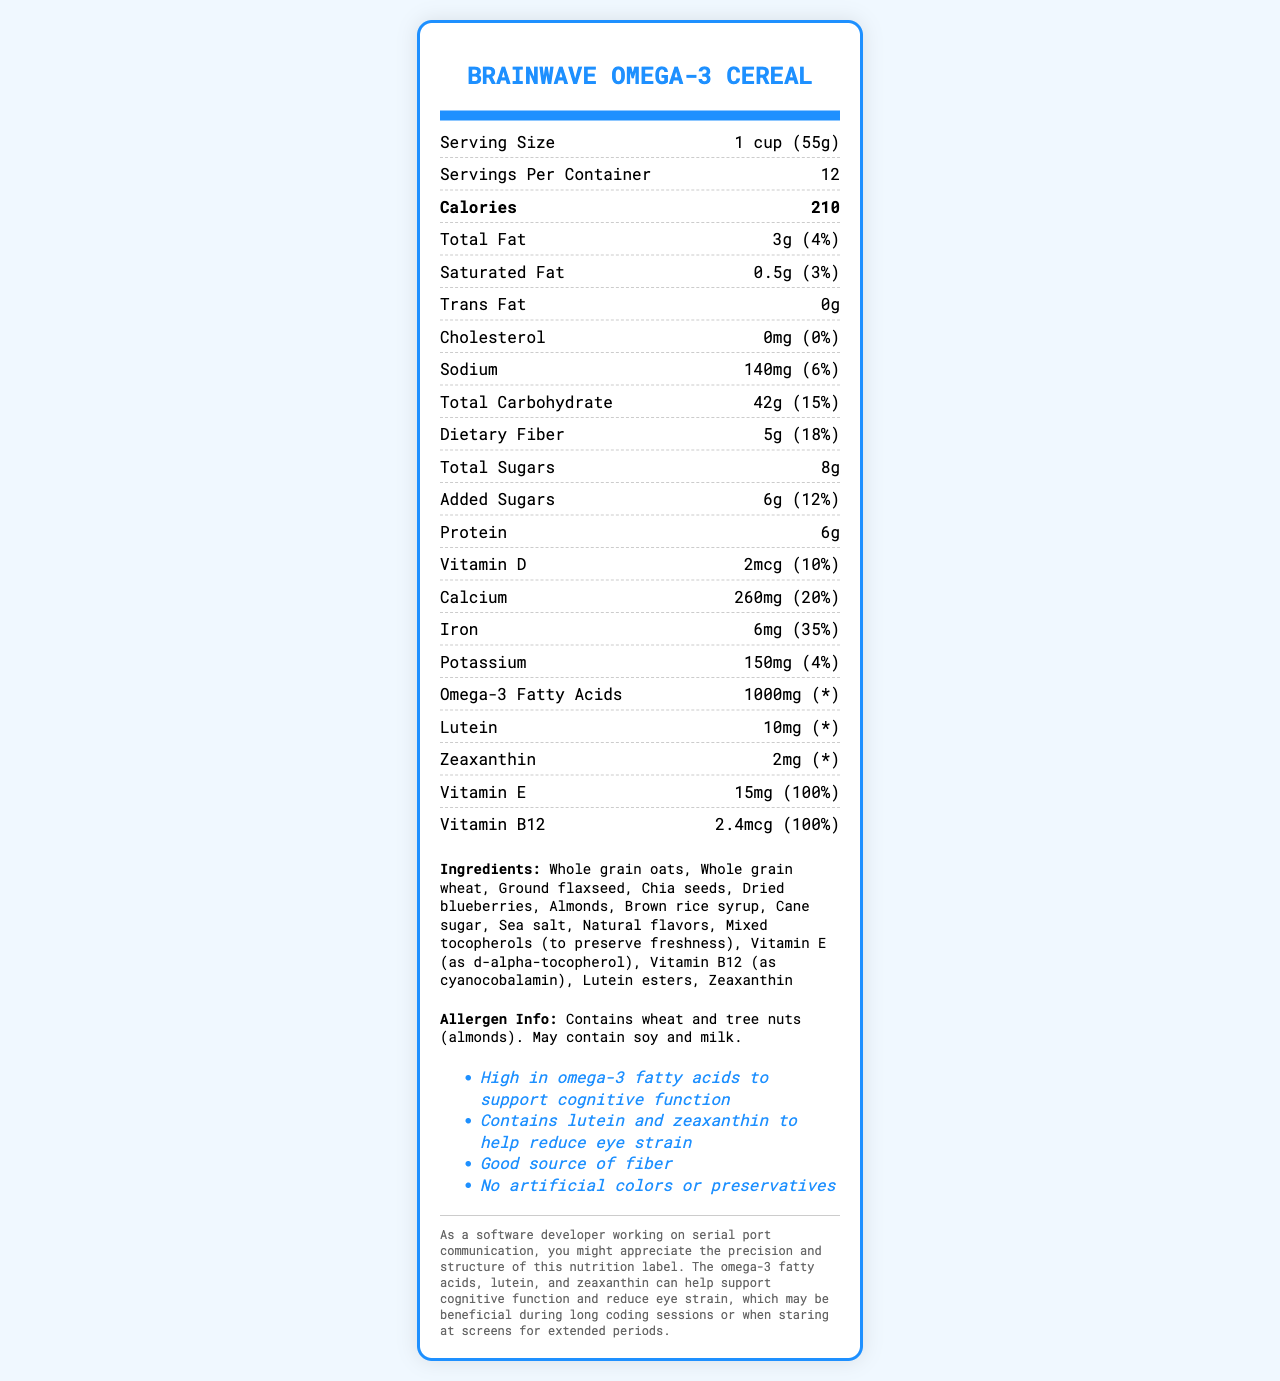What is the serving size for BrainWave Omega-3 Cereal? The serving size is explicitly mentioned in the Nutrition Facts section of the document.
Answer: 1 cup (55g) How many calories are there per serving of this cereal? The document shows that each serving contains 210 calories.
Answer: 210 What is the total fat content per serving? The total fat per serving is listed as 3 grams.
Answer: 3g How much dietary fiber is in each serving? The dietary fiber content per serving is mentioned as 5 grams in the Nutrition Facts.
Answer: 5g How much calcium does this cereal provide per serving, and what percentage of the daily value does this represent? The document states that each serving contains 260mg of calcium, which is 20% of the daily value.
Answer: 260mg, 20% Which of the following ingredients are listed as sources of omega-3 fatty acids? A. Whole grain oats, B. Ground flaxseed, C. Dried blueberries, D. Sea salt Ground flaxseed is known for its high omega-3 fatty acid content, thus it's the correct answer.
Answer: B Which vitamins cover 100% of the daily value per serving? A. Vitamin A and Vitamin C, B. Vitamin D and Calcium, C. Vitamin E and Vitamin B12 The document lists Vitamin E and Vitamin B12 as covering 100% of the daily value per serving.
Answer: C Does the product contain any artificial colors or preservatives? The claim statements in the document explicitly mention it contains no artificial colors or preservatives.
Answer: No Is this cereal suitable for someone who is allergic to almonds? The allergen info confirms that the product contains tree nuts (almonds).
Answer: No Summarize the main idea of the document. The main idea is captured by detailing the product's nutritional benefits, ingredients, and specific health claims, making it clear the cereal's intent to support cognitive and eye health.
Answer: The document provides detailed nutritional information for BrainWave Omega-3 Cereal, emphasizing its support for cognitive function and eye health. It outlines its contents, such as high omega-3 fatty acids, lutein, and zeaxanthin, while listing vitamins, minerals, and other ingredients. Additionally, it states claims such as being a good source of fiber and free from artificial colors or preservatives. How much potassium does each serving contain? The document lists the potassium content as 150mg per serving.
Answer: 150mg Identify one of the claim statements mentioned in the document. The claim statements section lists this specific claim among others.
Answer: High in omega-3 fatty acids to support cognitive function How many servings are in each container of this cereal? The document indicates there are 12 servings per container.
Answer: 12 What is the amount of added sugars per serving? The amount of added sugars per serving is listed as 6 grams.
Answer: 6g What additional nutrients are included to target eye health besides omega-3 fatty acids? The document specifies lutein (10mg) and zeaxanthin (2mg) as included nutrients to help reduce eye strain.
Answer: Lutein and zeaxanthin Does the cereal contain any cholesterol? The nutrition facts indicate 0mg of cholesterol per serving.
Answer: No Can we determine the price of BrainWave Omega-3 Cereal from this document? The document does not provide any information regarding the price of the cereal.
Answer: Cannot be determined 